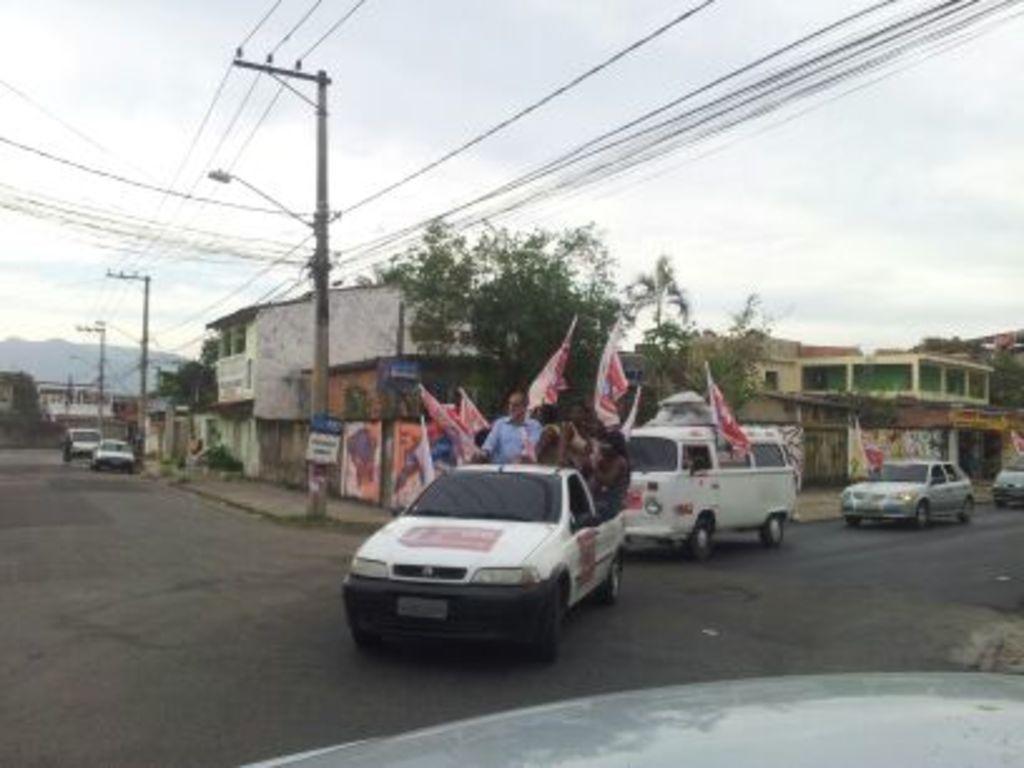Please provide a concise description of this image. In the image I can see a car in which there are some people holding some flags and around there are some other people, houses and some poles which has some wires. 